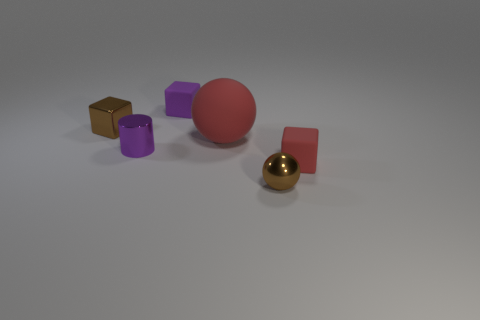Add 2 tiny purple things. How many objects exist? 8 Subtract all cylinders. How many objects are left? 5 Subtract all small matte cubes. Subtract all purple matte cubes. How many objects are left? 3 Add 5 tiny metal objects. How many tiny metal objects are left? 8 Add 3 rubber blocks. How many rubber blocks exist? 5 Subtract 0 gray cylinders. How many objects are left? 6 